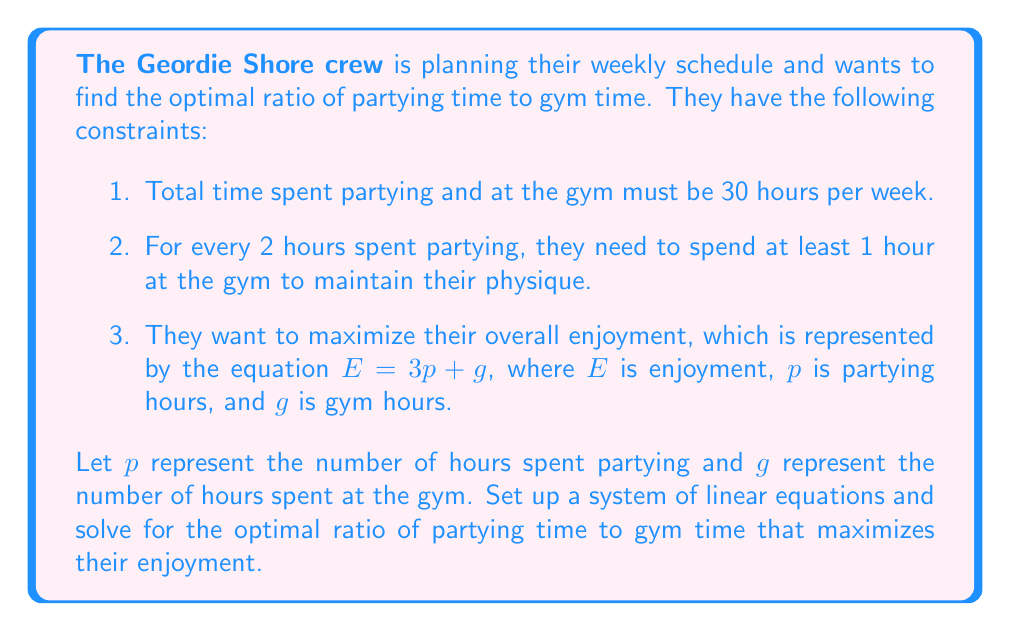Show me your answer to this math problem. Let's approach this step-by-step:

1) First, we can set up our constraints as equations:

   Total time constraint: $p + g = 30$
   Gym time constraint: $g \geq \frac{1}{2}p$

2) We want to maximize $E = 3p + g$

3) From the total time constraint, we can express $g$ in terms of $p$:
   $g = 30 - p$

4) Substituting this into the enjoyment equation:
   $E = 3p + (30 - p) = 2p + 30$

5) Now, we need to consider the gym time constraint:
   $30 - p \geq \frac{1}{2}p$
   $30 \geq \frac{3}{2}p$
   $20 \geq p$

6) So, to maximize enjoyment while satisfying all constraints, we should choose $p = 20$ (the maximum allowed value for $p$).

7) If $p = 20$, then $g = 30 - 20 = 10$

8) The ratio of partying time to gym time is therefore:
   $\frac{p}{g} = \frac{20}{10} = 2:1$

This ratio satisfies all constraints and maximizes enjoyment.
Answer: The optimal ratio of partying time to gym time is $2:1$. 